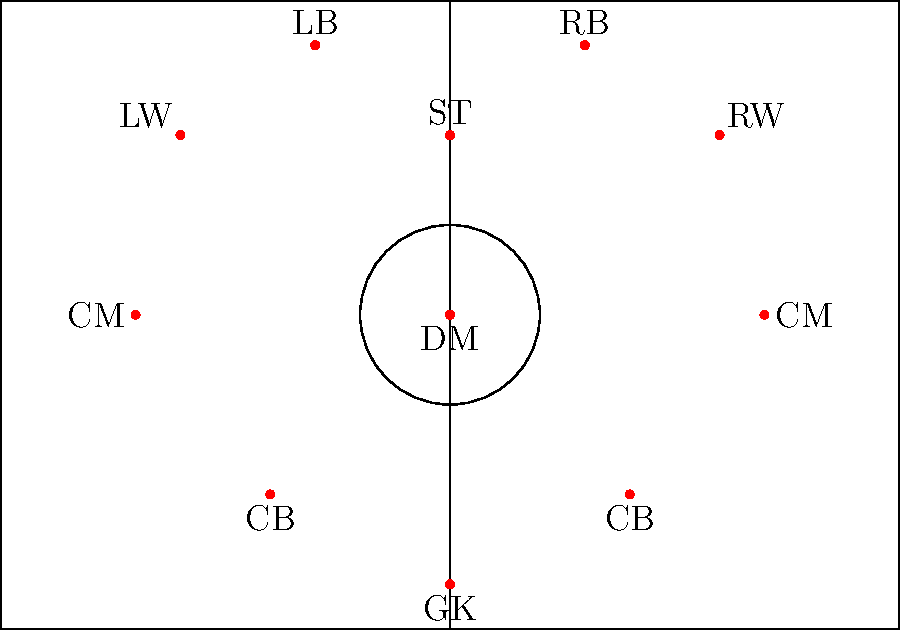In the 4-3-3 formation shown, which player position is crucial for maintaining defensive stability while also initiating attacks? Explain the tactical importance of this role in the overall team strategy. To answer this question, we need to analyze the roles of different positions in the 4-3-3 formation:

1. The formation consists of four defenders, three midfielders, and three forwards.

2. The key position for maintaining defensive stability while initiating attacks is the Defensive Midfielder (DM).

3. The DM's tactical importance:
   a) Defensive responsibilities:
      - Acts as a shield in front of the two center-backs
      - Helps to close down spaces between the defense and midfield
      - Provides additional cover against counter-attacks

   b) Offensive contributions:
      - Serves as the link between defense and attack
      - Often the first player to receive the ball from defenders when building up play
      - Can distribute the ball to more advanced midfielders or forwards

4. The DM's positioning allows them to:
   - Drop deep to form a back three when needed
   - Push forward to support attacks when the team is in possession

5. This role requires a player with excellent tactical awareness, passing ability, and defensive skills.

6. Famous examples of players excelling in this role include Sergio Busquets, N'Golo Kanté, and Casemiro.

The DM's ability to balance defensive stability and offensive initiation makes them crucial in the 4-3-3 formation, allowing the team to transition smoothly between defense and attack.
Answer: Defensive Midfielder (DM) 